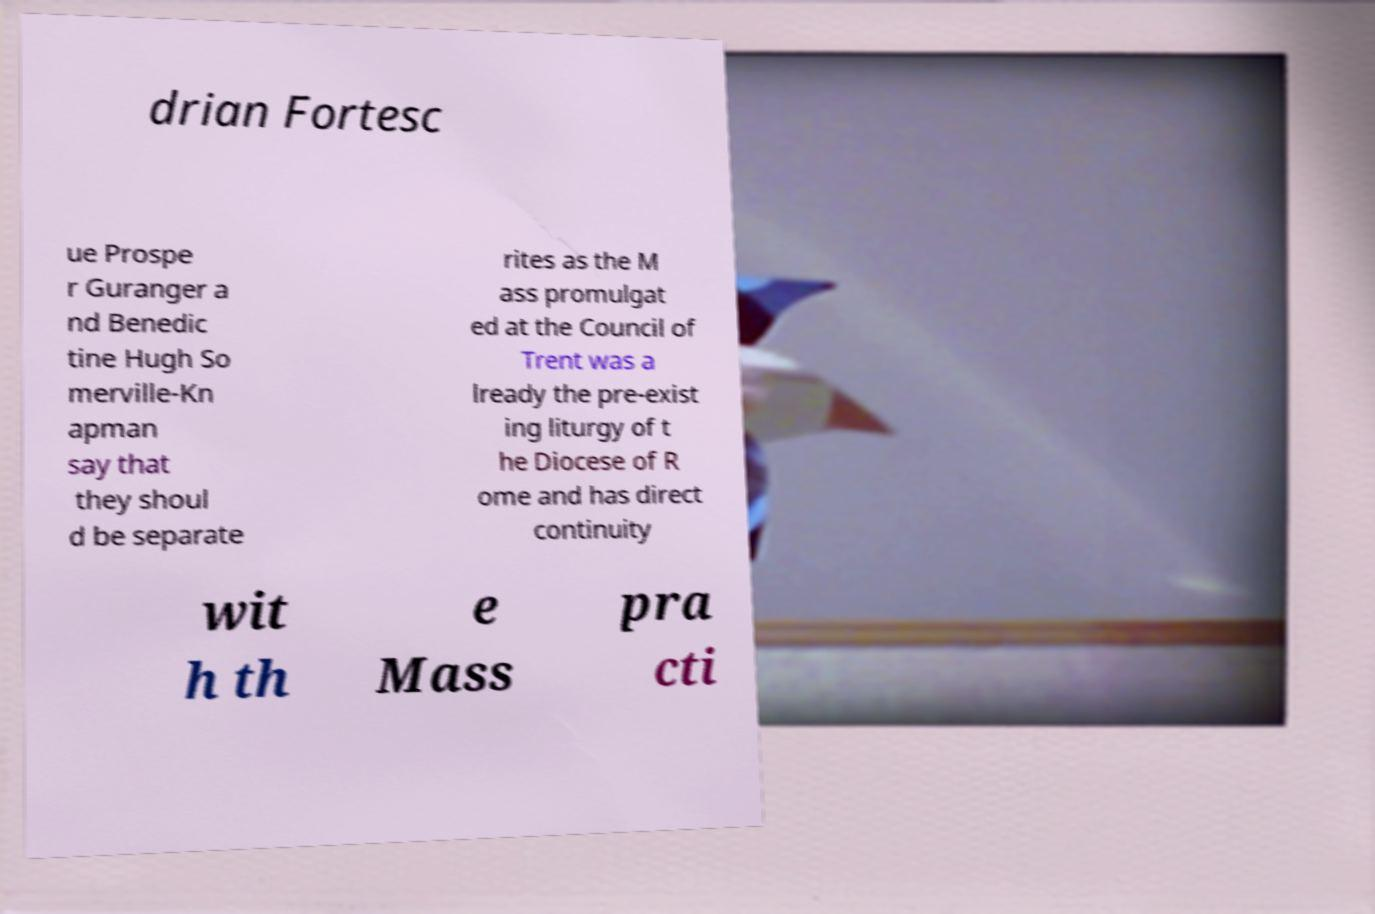I need the written content from this picture converted into text. Can you do that? drian Fortesc ue Prospe r Guranger a nd Benedic tine Hugh So merville-Kn apman say that they shoul d be separate rites as the M ass promulgat ed at the Council of Trent was a lready the pre-exist ing liturgy of t he Diocese of R ome and has direct continuity wit h th e Mass pra cti 